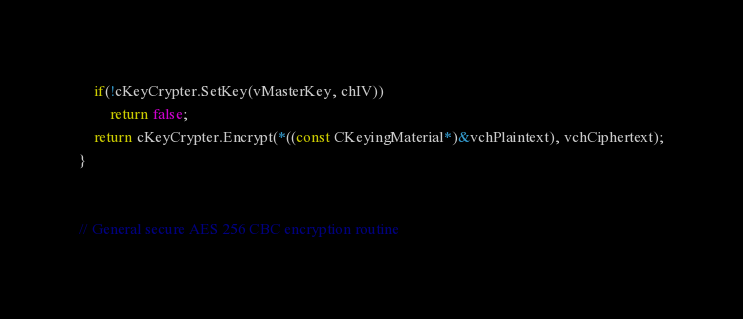Convert code to text. <code><loc_0><loc_0><loc_500><loc_500><_C++_>    if(!cKeyCrypter.SetKey(vMasterKey, chIV))
        return false;
    return cKeyCrypter.Encrypt(*((const CKeyingMaterial*)&vchPlaintext), vchCiphertext);
}


// General secure AES 256 CBC encryption routine</code> 